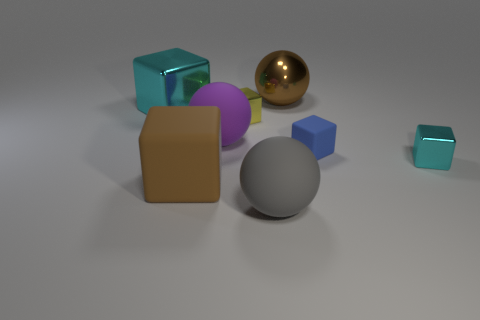What is the color of the shiny ball?
Offer a very short reply. Brown. Does the large metal thing on the left side of the gray thing have the same shape as the small yellow thing?
Make the answer very short. Yes. What number of things are small things in front of the purple thing or small cyan metal objects?
Ensure brevity in your answer.  2. Are there any shiny objects that have the same shape as the big brown matte thing?
Ensure brevity in your answer.  Yes. What is the shape of the yellow thing that is the same size as the blue cube?
Your answer should be very brief. Cube. What is the shape of the big brown object that is behind the shiny object to the right of the sphere that is behind the large cyan shiny thing?
Make the answer very short. Sphere. There is a purple thing; is it the same shape as the big brown object that is behind the small blue block?
Offer a terse response. Yes. What number of small things are yellow shiny objects or matte things?
Your response must be concise. 2. Are there any balls of the same size as the gray thing?
Your answer should be very brief. Yes. What is the color of the large matte thing behind the tiny cyan metal thing in front of the cyan shiny block left of the large rubber cube?
Ensure brevity in your answer.  Purple. 